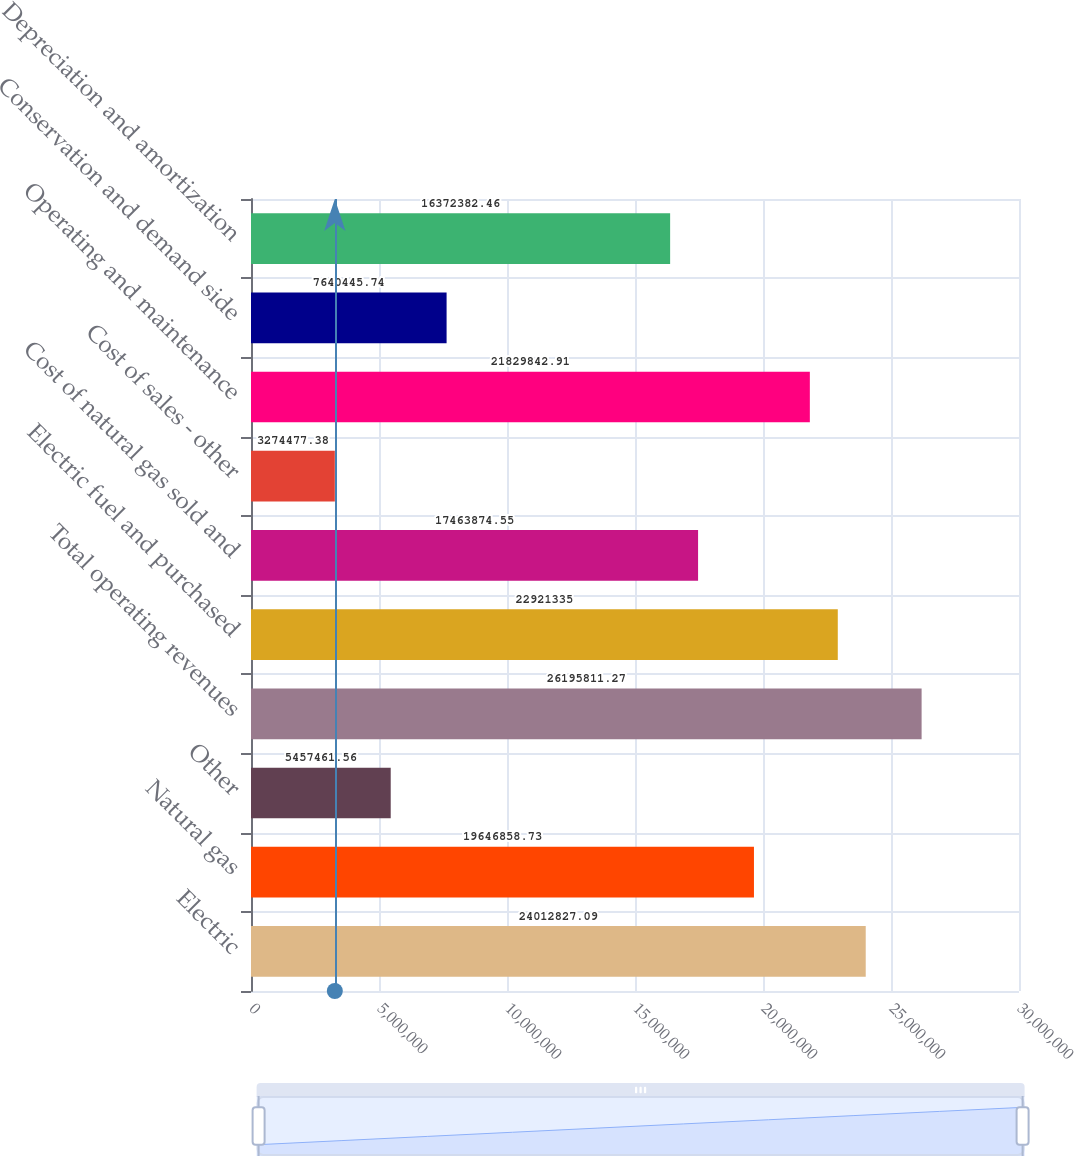Convert chart. <chart><loc_0><loc_0><loc_500><loc_500><bar_chart><fcel>Electric<fcel>Natural gas<fcel>Other<fcel>Total operating revenues<fcel>Electric fuel and purchased<fcel>Cost of natural gas sold and<fcel>Cost of sales - other<fcel>Operating and maintenance<fcel>Conservation and demand side<fcel>Depreciation and amortization<nl><fcel>2.40128e+07<fcel>1.96469e+07<fcel>5.45746e+06<fcel>2.61958e+07<fcel>2.29213e+07<fcel>1.74639e+07<fcel>3.27448e+06<fcel>2.18298e+07<fcel>7.64045e+06<fcel>1.63724e+07<nl></chart> 